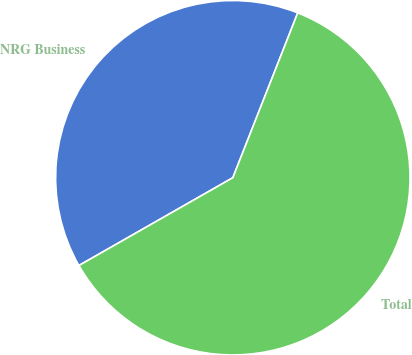Convert chart. <chart><loc_0><loc_0><loc_500><loc_500><pie_chart><fcel>NRG Business<fcel>Total<nl><fcel>39.22%<fcel>60.78%<nl></chart> 